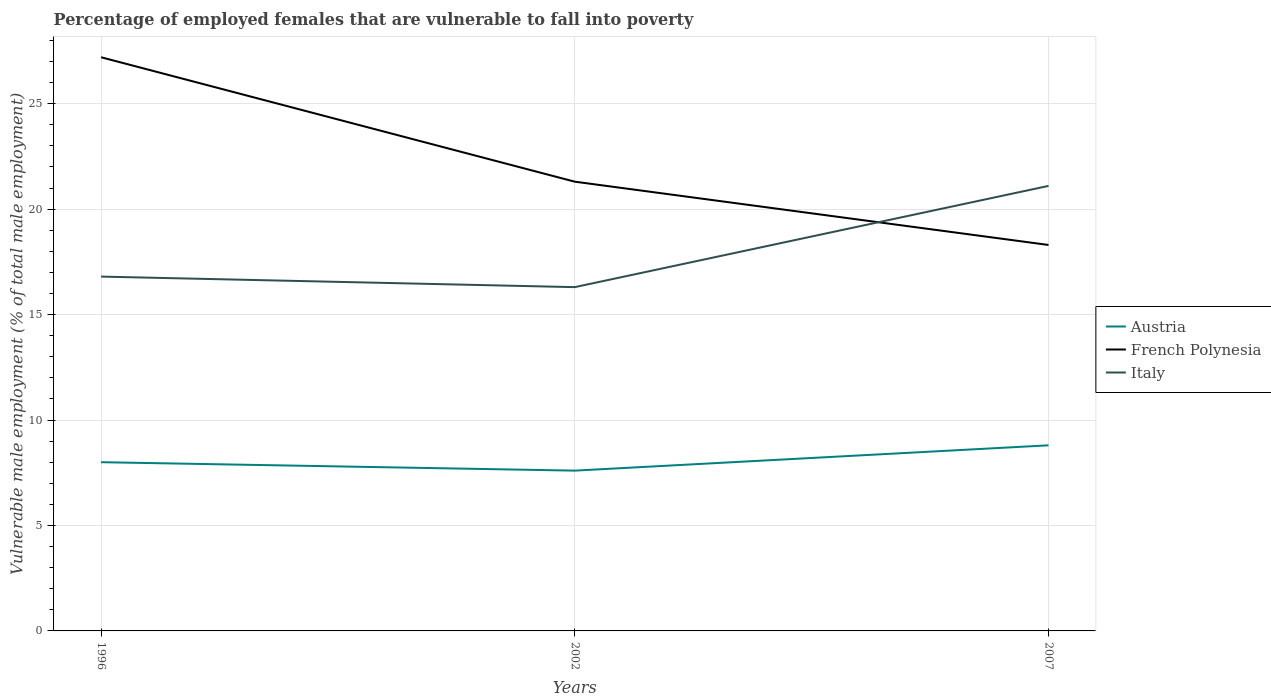How many different coloured lines are there?
Keep it short and to the point. 3. Does the line corresponding to French Polynesia intersect with the line corresponding to Austria?
Provide a short and direct response. No. Across all years, what is the maximum percentage of employed females who are vulnerable to fall into poverty in Austria?
Your response must be concise. 7.6. In which year was the percentage of employed females who are vulnerable to fall into poverty in Italy maximum?
Offer a very short reply. 2002. What is the total percentage of employed females who are vulnerable to fall into poverty in Italy in the graph?
Provide a short and direct response. 0.5. What is the difference between the highest and the second highest percentage of employed females who are vulnerable to fall into poverty in Austria?
Give a very brief answer. 1.2. What is the difference between the highest and the lowest percentage of employed females who are vulnerable to fall into poverty in French Polynesia?
Keep it short and to the point. 1. Is the percentage of employed females who are vulnerable to fall into poverty in Austria strictly greater than the percentage of employed females who are vulnerable to fall into poverty in Italy over the years?
Your answer should be very brief. Yes. How many lines are there?
Make the answer very short. 3. What is the difference between two consecutive major ticks on the Y-axis?
Your answer should be compact. 5. Are the values on the major ticks of Y-axis written in scientific E-notation?
Provide a succinct answer. No. Does the graph contain any zero values?
Offer a very short reply. No. Where does the legend appear in the graph?
Your answer should be compact. Center right. How many legend labels are there?
Provide a succinct answer. 3. How are the legend labels stacked?
Offer a terse response. Vertical. What is the title of the graph?
Provide a short and direct response. Percentage of employed females that are vulnerable to fall into poverty. What is the label or title of the Y-axis?
Make the answer very short. Vulnerable male employment (% of total male employment). What is the Vulnerable male employment (% of total male employment) in Austria in 1996?
Your answer should be compact. 8. What is the Vulnerable male employment (% of total male employment) in French Polynesia in 1996?
Offer a terse response. 27.2. What is the Vulnerable male employment (% of total male employment) of Italy in 1996?
Provide a succinct answer. 16.8. What is the Vulnerable male employment (% of total male employment) of Austria in 2002?
Keep it short and to the point. 7.6. What is the Vulnerable male employment (% of total male employment) of French Polynesia in 2002?
Offer a very short reply. 21.3. What is the Vulnerable male employment (% of total male employment) of Italy in 2002?
Keep it short and to the point. 16.3. What is the Vulnerable male employment (% of total male employment) in Austria in 2007?
Your answer should be very brief. 8.8. What is the Vulnerable male employment (% of total male employment) in French Polynesia in 2007?
Offer a terse response. 18.3. What is the Vulnerable male employment (% of total male employment) in Italy in 2007?
Your answer should be compact. 21.1. Across all years, what is the maximum Vulnerable male employment (% of total male employment) in Austria?
Provide a succinct answer. 8.8. Across all years, what is the maximum Vulnerable male employment (% of total male employment) of French Polynesia?
Your answer should be very brief. 27.2. Across all years, what is the maximum Vulnerable male employment (% of total male employment) in Italy?
Give a very brief answer. 21.1. Across all years, what is the minimum Vulnerable male employment (% of total male employment) of Austria?
Provide a succinct answer. 7.6. Across all years, what is the minimum Vulnerable male employment (% of total male employment) in French Polynesia?
Offer a very short reply. 18.3. Across all years, what is the minimum Vulnerable male employment (% of total male employment) of Italy?
Give a very brief answer. 16.3. What is the total Vulnerable male employment (% of total male employment) of Austria in the graph?
Ensure brevity in your answer.  24.4. What is the total Vulnerable male employment (% of total male employment) of French Polynesia in the graph?
Your answer should be very brief. 66.8. What is the total Vulnerable male employment (% of total male employment) of Italy in the graph?
Your answer should be very brief. 54.2. What is the difference between the Vulnerable male employment (% of total male employment) of Austria in 1996 and that in 2002?
Provide a short and direct response. 0.4. What is the difference between the Vulnerable male employment (% of total male employment) in French Polynesia in 1996 and that in 2002?
Your answer should be compact. 5.9. What is the difference between the Vulnerable male employment (% of total male employment) in Italy in 1996 and that in 2002?
Your answer should be compact. 0.5. What is the difference between the Vulnerable male employment (% of total male employment) of Austria in 1996 and that in 2007?
Ensure brevity in your answer.  -0.8. What is the difference between the Vulnerable male employment (% of total male employment) of Italy in 1996 and that in 2007?
Provide a succinct answer. -4.3. What is the difference between the Vulnerable male employment (% of total male employment) of French Polynesia in 1996 and the Vulnerable male employment (% of total male employment) of Italy in 2002?
Your answer should be compact. 10.9. What is the average Vulnerable male employment (% of total male employment) in Austria per year?
Ensure brevity in your answer.  8.13. What is the average Vulnerable male employment (% of total male employment) in French Polynesia per year?
Your answer should be compact. 22.27. What is the average Vulnerable male employment (% of total male employment) of Italy per year?
Provide a short and direct response. 18.07. In the year 1996, what is the difference between the Vulnerable male employment (% of total male employment) in Austria and Vulnerable male employment (% of total male employment) in French Polynesia?
Your answer should be compact. -19.2. In the year 1996, what is the difference between the Vulnerable male employment (% of total male employment) of Austria and Vulnerable male employment (% of total male employment) of Italy?
Provide a succinct answer. -8.8. In the year 1996, what is the difference between the Vulnerable male employment (% of total male employment) of French Polynesia and Vulnerable male employment (% of total male employment) of Italy?
Your answer should be very brief. 10.4. In the year 2002, what is the difference between the Vulnerable male employment (% of total male employment) in Austria and Vulnerable male employment (% of total male employment) in French Polynesia?
Provide a succinct answer. -13.7. In the year 2007, what is the difference between the Vulnerable male employment (% of total male employment) in Austria and Vulnerable male employment (% of total male employment) in French Polynesia?
Your response must be concise. -9.5. In the year 2007, what is the difference between the Vulnerable male employment (% of total male employment) in Austria and Vulnerable male employment (% of total male employment) in Italy?
Keep it short and to the point. -12.3. In the year 2007, what is the difference between the Vulnerable male employment (% of total male employment) of French Polynesia and Vulnerable male employment (% of total male employment) of Italy?
Your response must be concise. -2.8. What is the ratio of the Vulnerable male employment (% of total male employment) in Austria in 1996 to that in 2002?
Your response must be concise. 1.05. What is the ratio of the Vulnerable male employment (% of total male employment) in French Polynesia in 1996 to that in 2002?
Provide a short and direct response. 1.28. What is the ratio of the Vulnerable male employment (% of total male employment) in Italy in 1996 to that in 2002?
Give a very brief answer. 1.03. What is the ratio of the Vulnerable male employment (% of total male employment) of French Polynesia in 1996 to that in 2007?
Ensure brevity in your answer.  1.49. What is the ratio of the Vulnerable male employment (% of total male employment) in Italy in 1996 to that in 2007?
Give a very brief answer. 0.8. What is the ratio of the Vulnerable male employment (% of total male employment) in Austria in 2002 to that in 2007?
Give a very brief answer. 0.86. What is the ratio of the Vulnerable male employment (% of total male employment) of French Polynesia in 2002 to that in 2007?
Ensure brevity in your answer.  1.16. What is the ratio of the Vulnerable male employment (% of total male employment) of Italy in 2002 to that in 2007?
Your answer should be compact. 0.77. What is the difference between the highest and the lowest Vulnerable male employment (% of total male employment) of Austria?
Make the answer very short. 1.2. What is the difference between the highest and the lowest Vulnerable male employment (% of total male employment) of French Polynesia?
Provide a short and direct response. 8.9. 